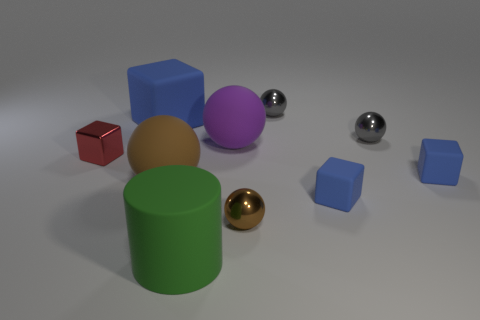Is the blue cube that is on the left side of the tiny brown metallic thing made of the same material as the green cylinder?
Offer a terse response. Yes. Are there fewer large green matte things that are to the right of the green rubber cylinder than big blue objects behind the large blue matte cube?
Offer a terse response. No. How many other things are made of the same material as the green cylinder?
Provide a succinct answer. 5. What is the material of the brown sphere that is the same size as the red object?
Provide a succinct answer. Metal. Are there fewer large purple spheres right of the large green cylinder than matte blocks?
Provide a short and direct response. Yes. What is the shape of the gray shiny object that is on the right side of the small gray thing behind the matte cube on the left side of the brown rubber sphere?
Ensure brevity in your answer.  Sphere. What is the size of the blue block behind the tiny red thing?
Provide a succinct answer. Large. There is a blue matte object that is the same size as the green matte thing; what is its shape?
Offer a very short reply. Cube. How many objects are large gray rubber things or tiny metal spheres in front of the purple rubber sphere?
Your answer should be compact. 1. There is a brown ball to the left of the metallic ball that is in front of the brown matte ball; what number of large spheres are in front of it?
Offer a terse response. 0. 